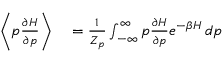Convert formula to latex. <formula><loc_0><loc_0><loc_500><loc_500>\begin{array} { r l } { \left \langle p \frac { \partial H } { \partial p } \right \rangle } & = \frac { 1 } { Z _ { p } } \int _ { - \infty } ^ { \infty } p \frac { \partial H } { \partial p } e ^ { - \beta H } \, d p } \end{array}</formula> 